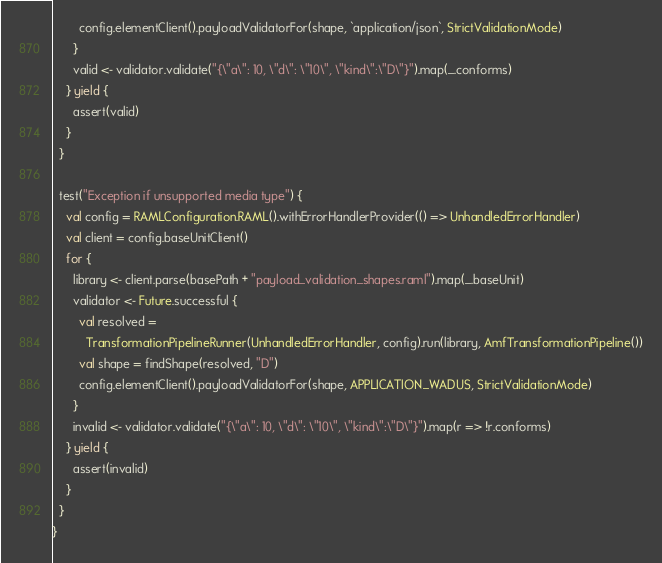<code> <loc_0><loc_0><loc_500><loc_500><_Scala_>        config.elementClient().payloadValidatorFor(shape, `application/json`, StrictValidationMode)
      }
      valid <- validator.validate("{\"a\": 10, \"d\": \"10\", \"kind\":\"D\"}").map(_.conforms)
    } yield {
      assert(valid)
    }
  }

  test("Exception if unsupported media type") {
    val config = RAMLConfiguration.RAML().withErrorHandlerProvider(() => UnhandledErrorHandler)
    val client = config.baseUnitClient()
    for {
      library <- client.parse(basePath + "payload_validation_shapes.raml").map(_.baseUnit)
      validator <- Future.successful {
        val resolved =
          TransformationPipelineRunner(UnhandledErrorHandler, config).run(library, AmfTransformationPipeline())
        val shape = findShape(resolved, "D")
        config.elementClient().payloadValidatorFor(shape, APPLICATION_WADUS, StrictValidationMode)
      }
      invalid <- validator.validate("{\"a\": 10, \"d\": \"10\", \"kind\":\"D\"}").map(r => !r.conforms)
    } yield {
      assert(invalid)
    }
  }
}
</code> 